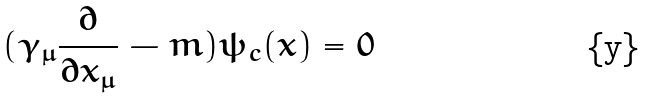<formula> <loc_0><loc_0><loc_500><loc_500>( \gamma _ { \mu } \frac { \partial } { \partial x _ { \mu } } - m ) \psi _ { c } ( x ) = 0</formula> 